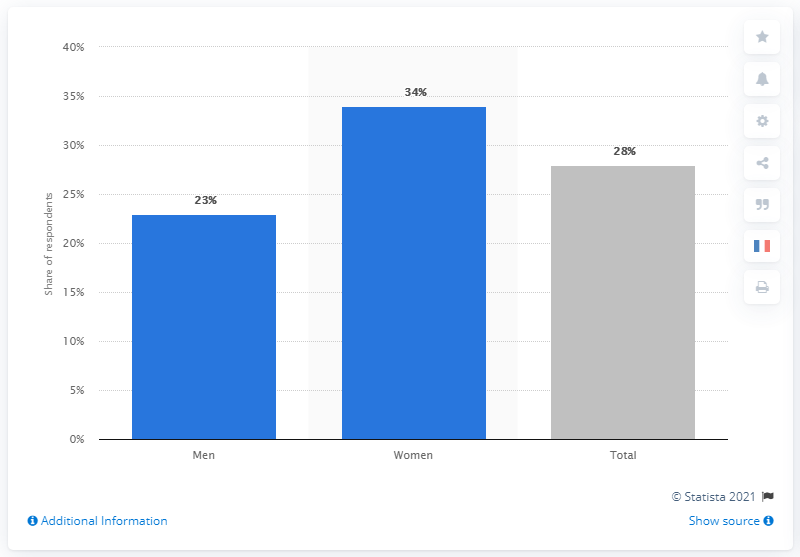Can you give me an overview of the data representation in this chart? Certainly! This bar chart represents the share of respondents who are worried about Coronavirus, with separate bars indicating the percentage of men, women, and the total population. The percentages are 23% for men, 34% for women, and 28% for the entire group of respondents. 